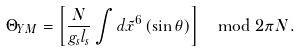Convert formula to latex. <formula><loc_0><loc_0><loc_500><loc_500>\Theta _ { Y M } = \left [ \frac { N } { g _ { s } l _ { s } } \int d \tilde { x } ^ { 6 } \, ( \sin \theta ) \right ] \mod 2 \pi N .</formula> 